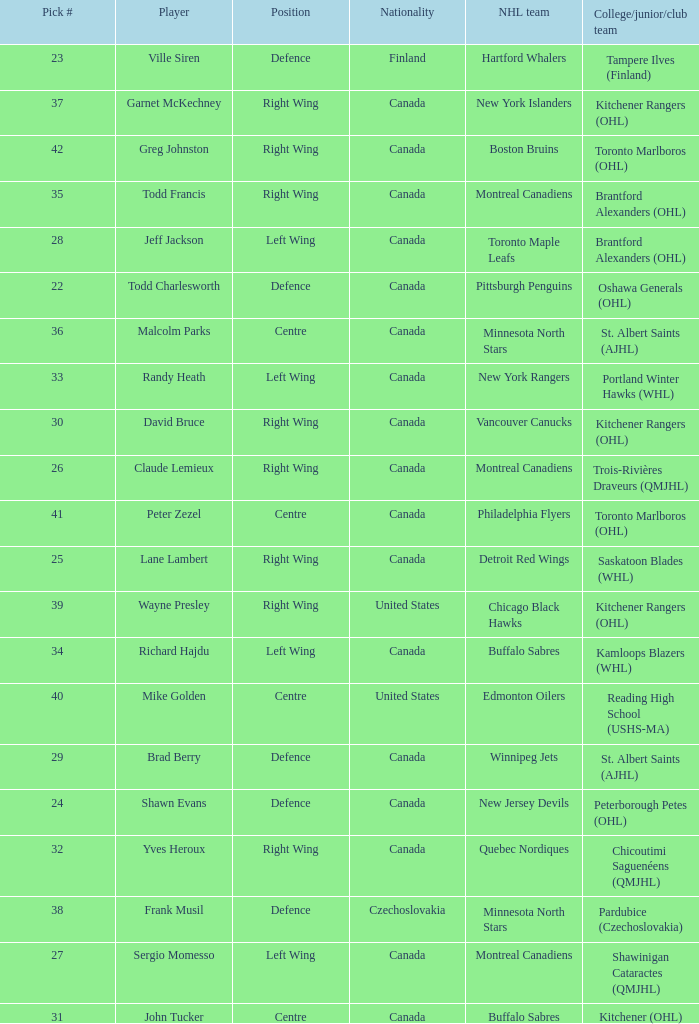What is the position for the nhl team toronto maple leafs? Left Wing. 